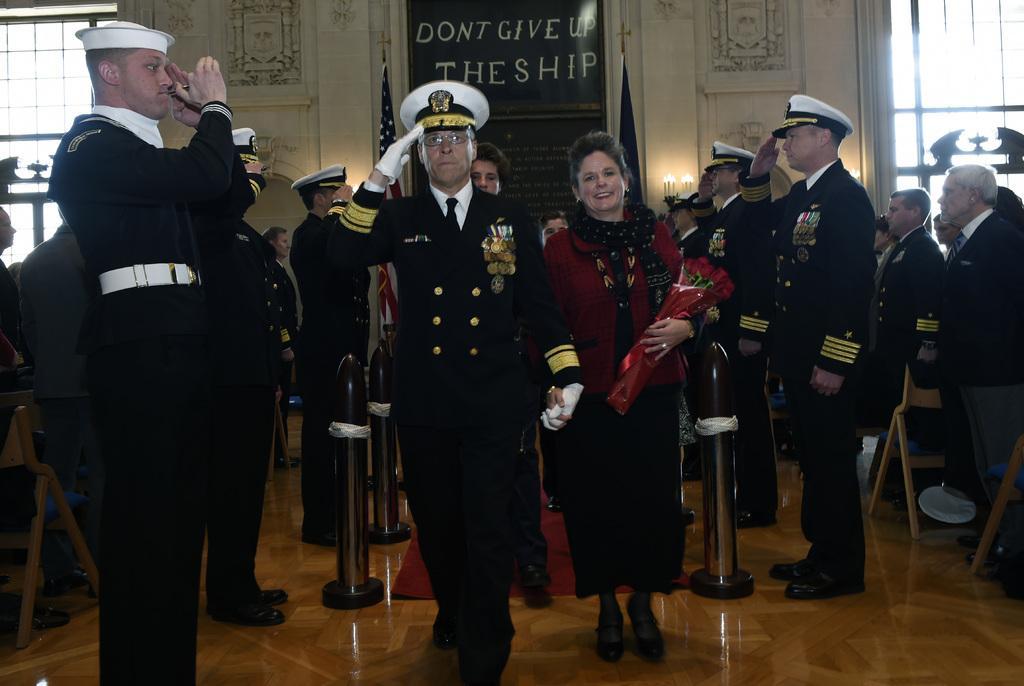In one or two sentences, can you explain what this image depicts? Here in this picture in the middle we can see a person holding a woman's hand walking on the floor over there and we can see he is wearing a uniform with gloves and cap on him and beside them on either side we can see people standing in uniforms with caps on them saluting over there and we can see the woman is smiling and carrying a flower bouquet in her hand and we can also see other people present over there and we can also see chairs present and behind them we can see a banner present and we can also see flag posts present and on either side of it we can see windows present over there. 